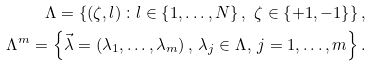Convert formula to latex. <formula><loc_0><loc_0><loc_500><loc_500>\Lambda = \left \{ \left ( \zeta , l \right ) \colon l \in \left \{ 1 , \dots , N \right \} , \ \zeta \in \left \{ + 1 , - 1 \right \} \right \} , \\ \Lambda ^ { m } = \left \{ \vec { \lambda } = \left ( \lambda _ { 1 } , \dots , \lambda _ { m } \right ) , \ \lambda _ { j } \in \Lambda , \ j = 1 , \dots , m \right \} .</formula> 